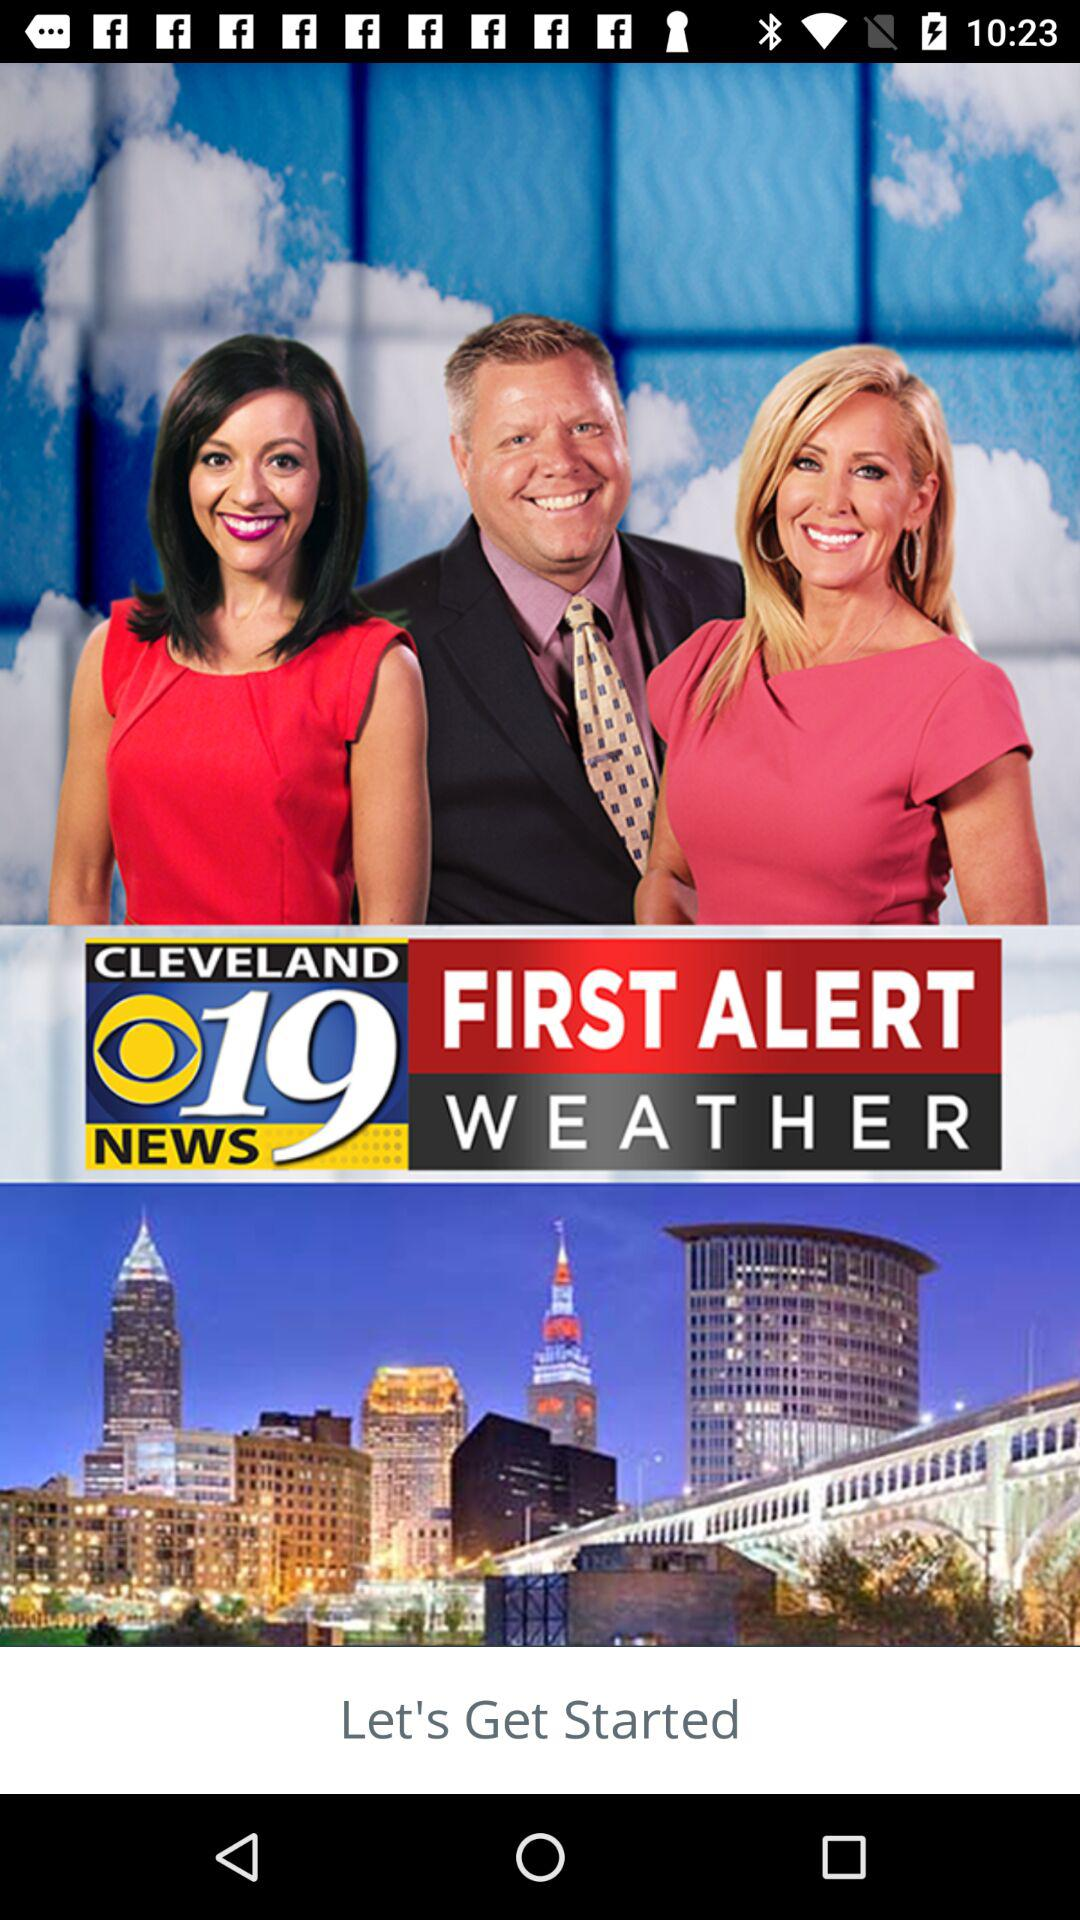How cold will it be tomorrow?
When the provided information is insufficient, respond with <no answer>. <no answer> 